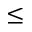Convert formula to latex. <formula><loc_0><loc_0><loc_500><loc_500>\leq</formula> 